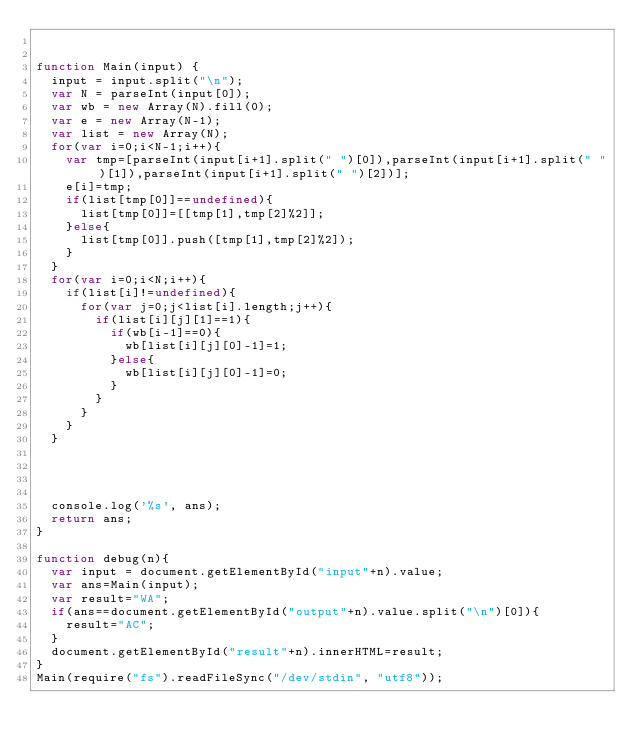<code> <loc_0><loc_0><loc_500><loc_500><_JavaScript_>

function Main(input) {
  input = input.split("\n");
  var N = parseInt(input[0]);
  var wb = new Array(N).fill(0);
  var e = new Array(N-1);
  var list = new Array(N);
  for(var i=0;i<N-1;i++){
    var tmp=[parseInt(input[i+1].split(" ")[0]),parseInt(input[i+1].split(" ")[1]),parseInt(input[i+1].split(" ")[2])];
    e[i]=tmp;
    if(list[tmp[0]]==undefined){
      list[tmp[0]]=[[tmp[1],tmp[2]%2]];
    }else{
      list[tmp[0]].push([tmp[1],tmp[2]%2]);
    }
  }
  for(var i=0;i<N;i++){
    if(list[i]!=undefined){
      for(var j=0;j<list[i].length;j++){
        if(list[i][j][1]==1){
          if(wb[i-1]==0){
            wb[list[i][j][0]-1]=1;
          }else{
            wb[list[i][j][0]-1]=0;
          }
        }
      }
    }
  }


  

  console.log('%s', ans);
  return ans;
}

function debug(n){
  var input = document.getElementById("input"+n).value;
  var ans=Main(input);
  var result="WA";
  if(ans==document.getElementById("output"+n).value.split("\n")[0]){
    result="AC";
  }
  document.getElementById("result"+n).innerHTML=result;
}
Main(require("fs").readFileSync("/dev/stdin", "utf8"));</code> 